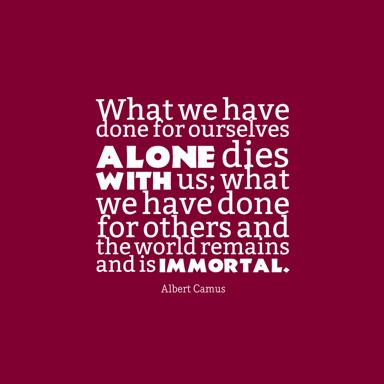What is the essence of the quote by Albert Camus? The quote by Albert Camus underscores the timeless wisdom that actions meant to benefit others create enduring legacies, transcending our own mortality. By stating, "What we have done for ourselves alone dies with us; what we have done for others and the world remains and is immortal," Camus highlights the impermanence of self-serving deeds compared to the perpetual impact of altruistic actions. It reminds us that true significance is achieved through our contributions to the collective rather than the individual. 